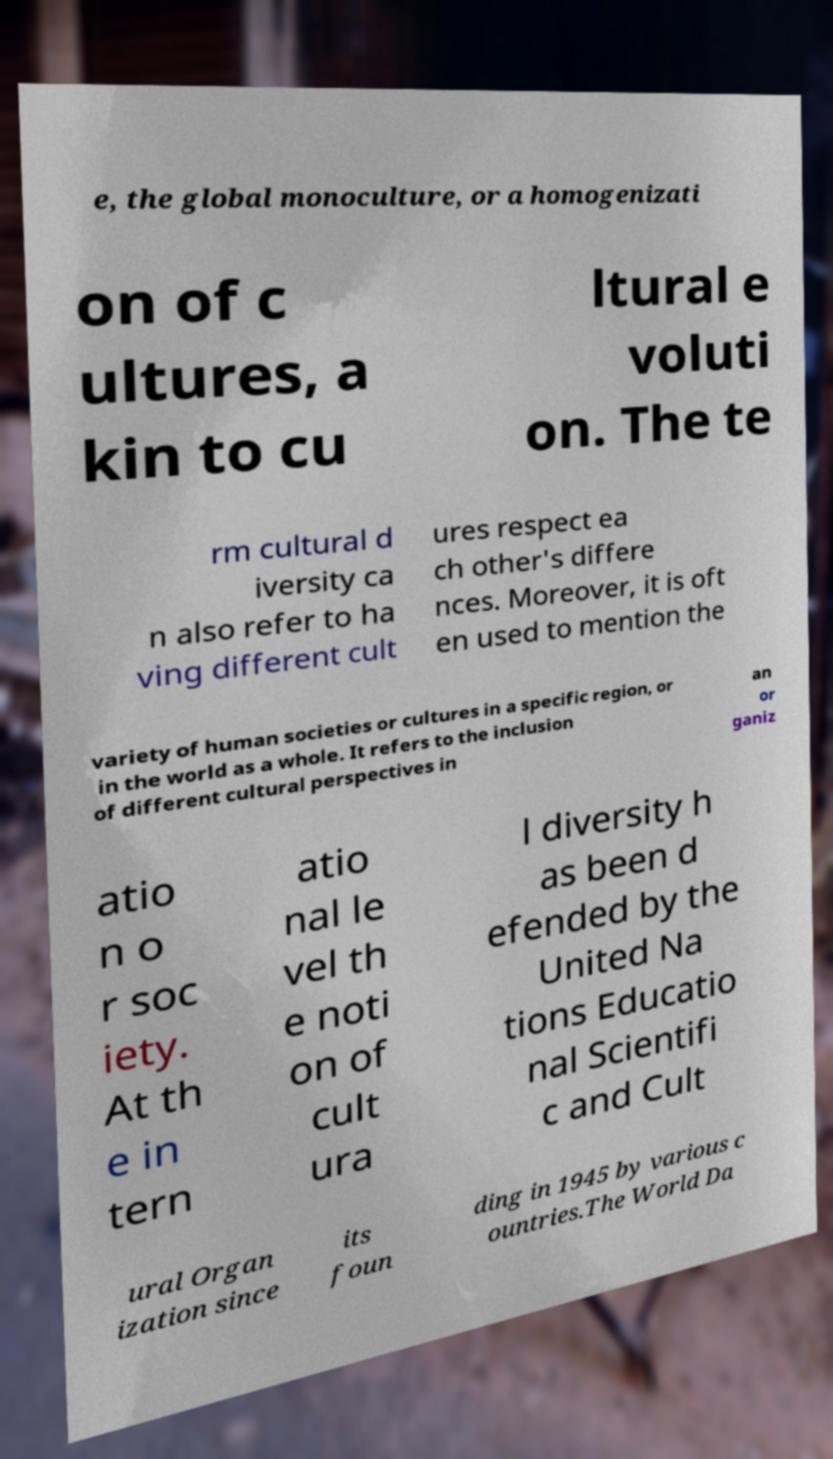Please read and relay the text visible in this image. What does it say? e, the global monoculture, or a homogenizati on of c ultures, a kin to cu ltural e voluti on. The te rm cultural d iversity ca n also refer to ha ving different cult ures respect ea ch other's differe nces. Moreover, it is oft en used to mention the variety of human societies or cultures in a specific region, or in the world as a whole. It refers to the inclusion of different cultural perspectives in an or ganiz atio n o r soc iety. At th e in tern atio nal le vel th e noti on of cult ura l diversity h as been d efended by the United Na tions Educatio nal Scientifi c and Cult ural Organ ization since its foun ding in 1945 by various c ountries.The World Da 